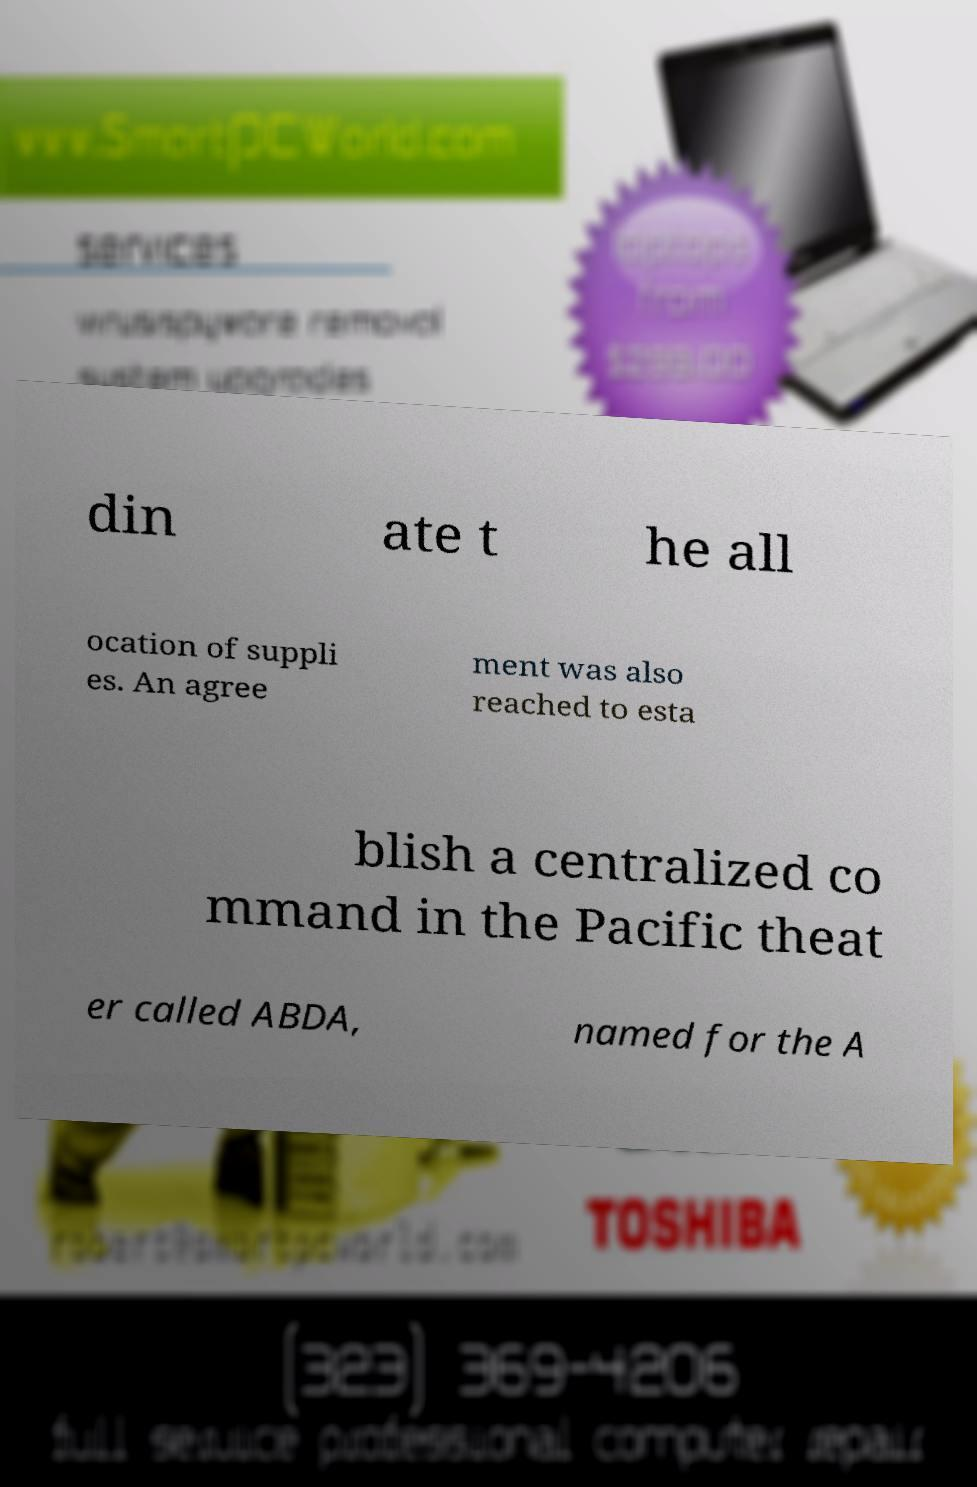Can you accurately transcribe the text from the provided image for me? din ate t he all ocation of suppli es. An agree ment was also reached to esta blish a centralized co mmand in the Pacific theat er called ABDA, named for the A 